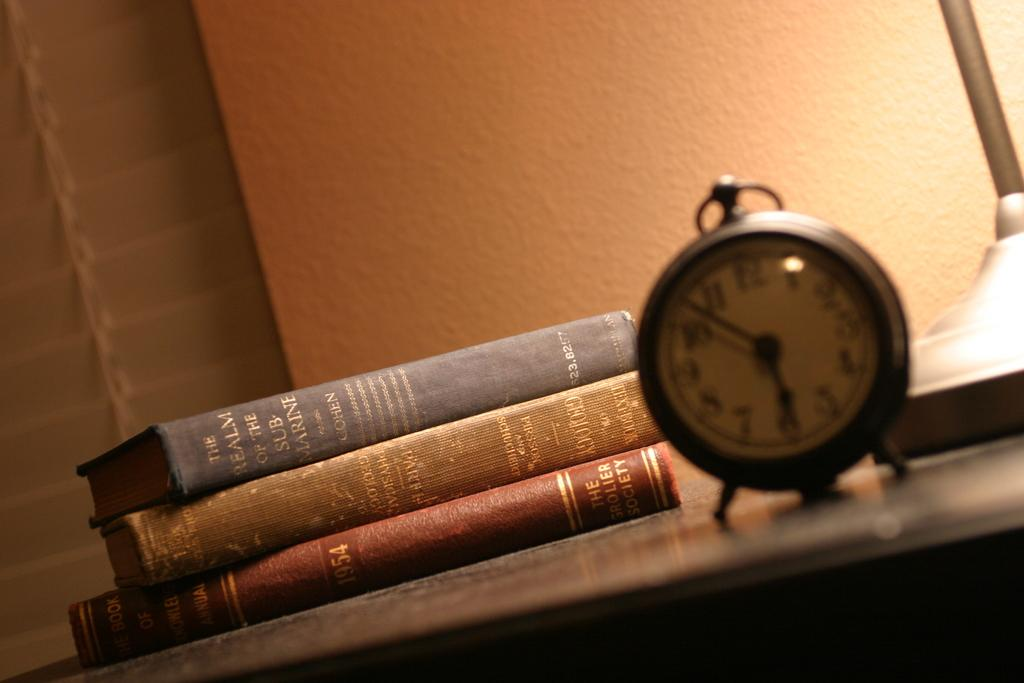<image>
Render a clear and concise summary of the photo. Three books and a wind up alarm clock next to the base of a lamp. 